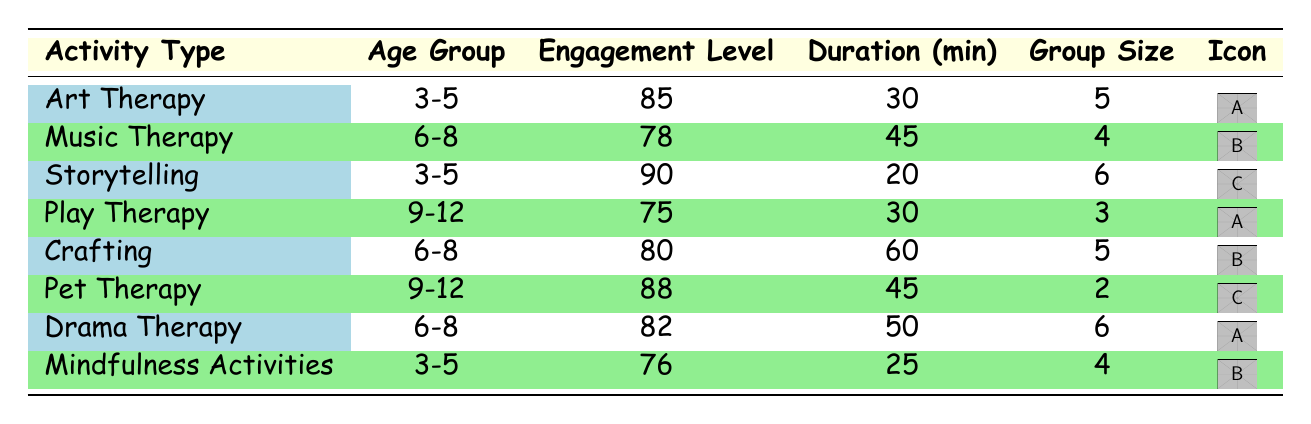What is the engagement level for Storytelling in the 3-5 age group? The table indicates that Storytelling has an engagement level of 90 for the 3-5 age group.
Answer: 90 Which activity type has the highest engagement level for the 9-12 age group? In the 9-12 age group, Pet Therapy has the highest engagement level at 88, compared to the other activities listed.
Answer: Pet Therapy What is the average group size for Art Therapy across different age groups? Summing the group sizes for Art Therapy gives us 5 (3-5 age group) + 5 (9-12 age group) = 10. Dividing by the number of entries (2) results in an average group size of 10 / 2 = 5.
Answer: 5 True or False: Crafting has a higher engagement level than Music Therapy in the 6-8 age group. The engagement level for Crafting (80) is indeed higher than that of Music Therapy (78) for the 6-8 age group, confirming the statement as true.
Answer: True What is the total engagement level for Play Therapy across all age groups? The engagement level for Play Therapy in the 3-5 age group is 92, and for the 9-12 age group, it's 75. Adding these together results in 92 + 75 = 167.
Answer: 167 Which activity has the shortest duration time and what is that time? Referring to the provided data, Storytelling has the shortest duration time of 20 minutes for the 3-5 age group.
Answer: 20 minutes What is the difference in engagement level between Music Therapy for the 3-5 age group and Drama Therapy for the 6-8 age group? The engagement level for Music Therapy (3-5 age group) is 83, and for Drama Therapy (6-8 age group) is 82. The difference is 83 - 82 = 1.
Answer: 1 How many activity types have an engagement level greater than 80? The activities with engagement levels greater than 80 are Art Therapy (85 for 3-5), Storytelling (90 for 3-5), Play Therapy (92 for 3-5), Pet Therapy (88 for 9-12), Drama Therapy (90 for 9-12). In total, there are 5 such activity types.
Answer: 5 What is the engagement level median for the 3-5 age group? The engagement levels in this group are 85 (Art Therapy), 90 (Storytelling), 92 (Play Therapy), and 83 (Music Therapy). Arranging them gives 83, 85, 90, 92. The median is the average of the two middle values: (85 + 90) / 2 = 87.5.
Answer: 87.5 How many activities involve a group size of 3 for the age group 9-12? Looking through the data, there are two activities (Play Therapy and Crafting) that involve a group size of 3 in the 9-12 age group, confirming a count of 2 activities.
Answer: 2 